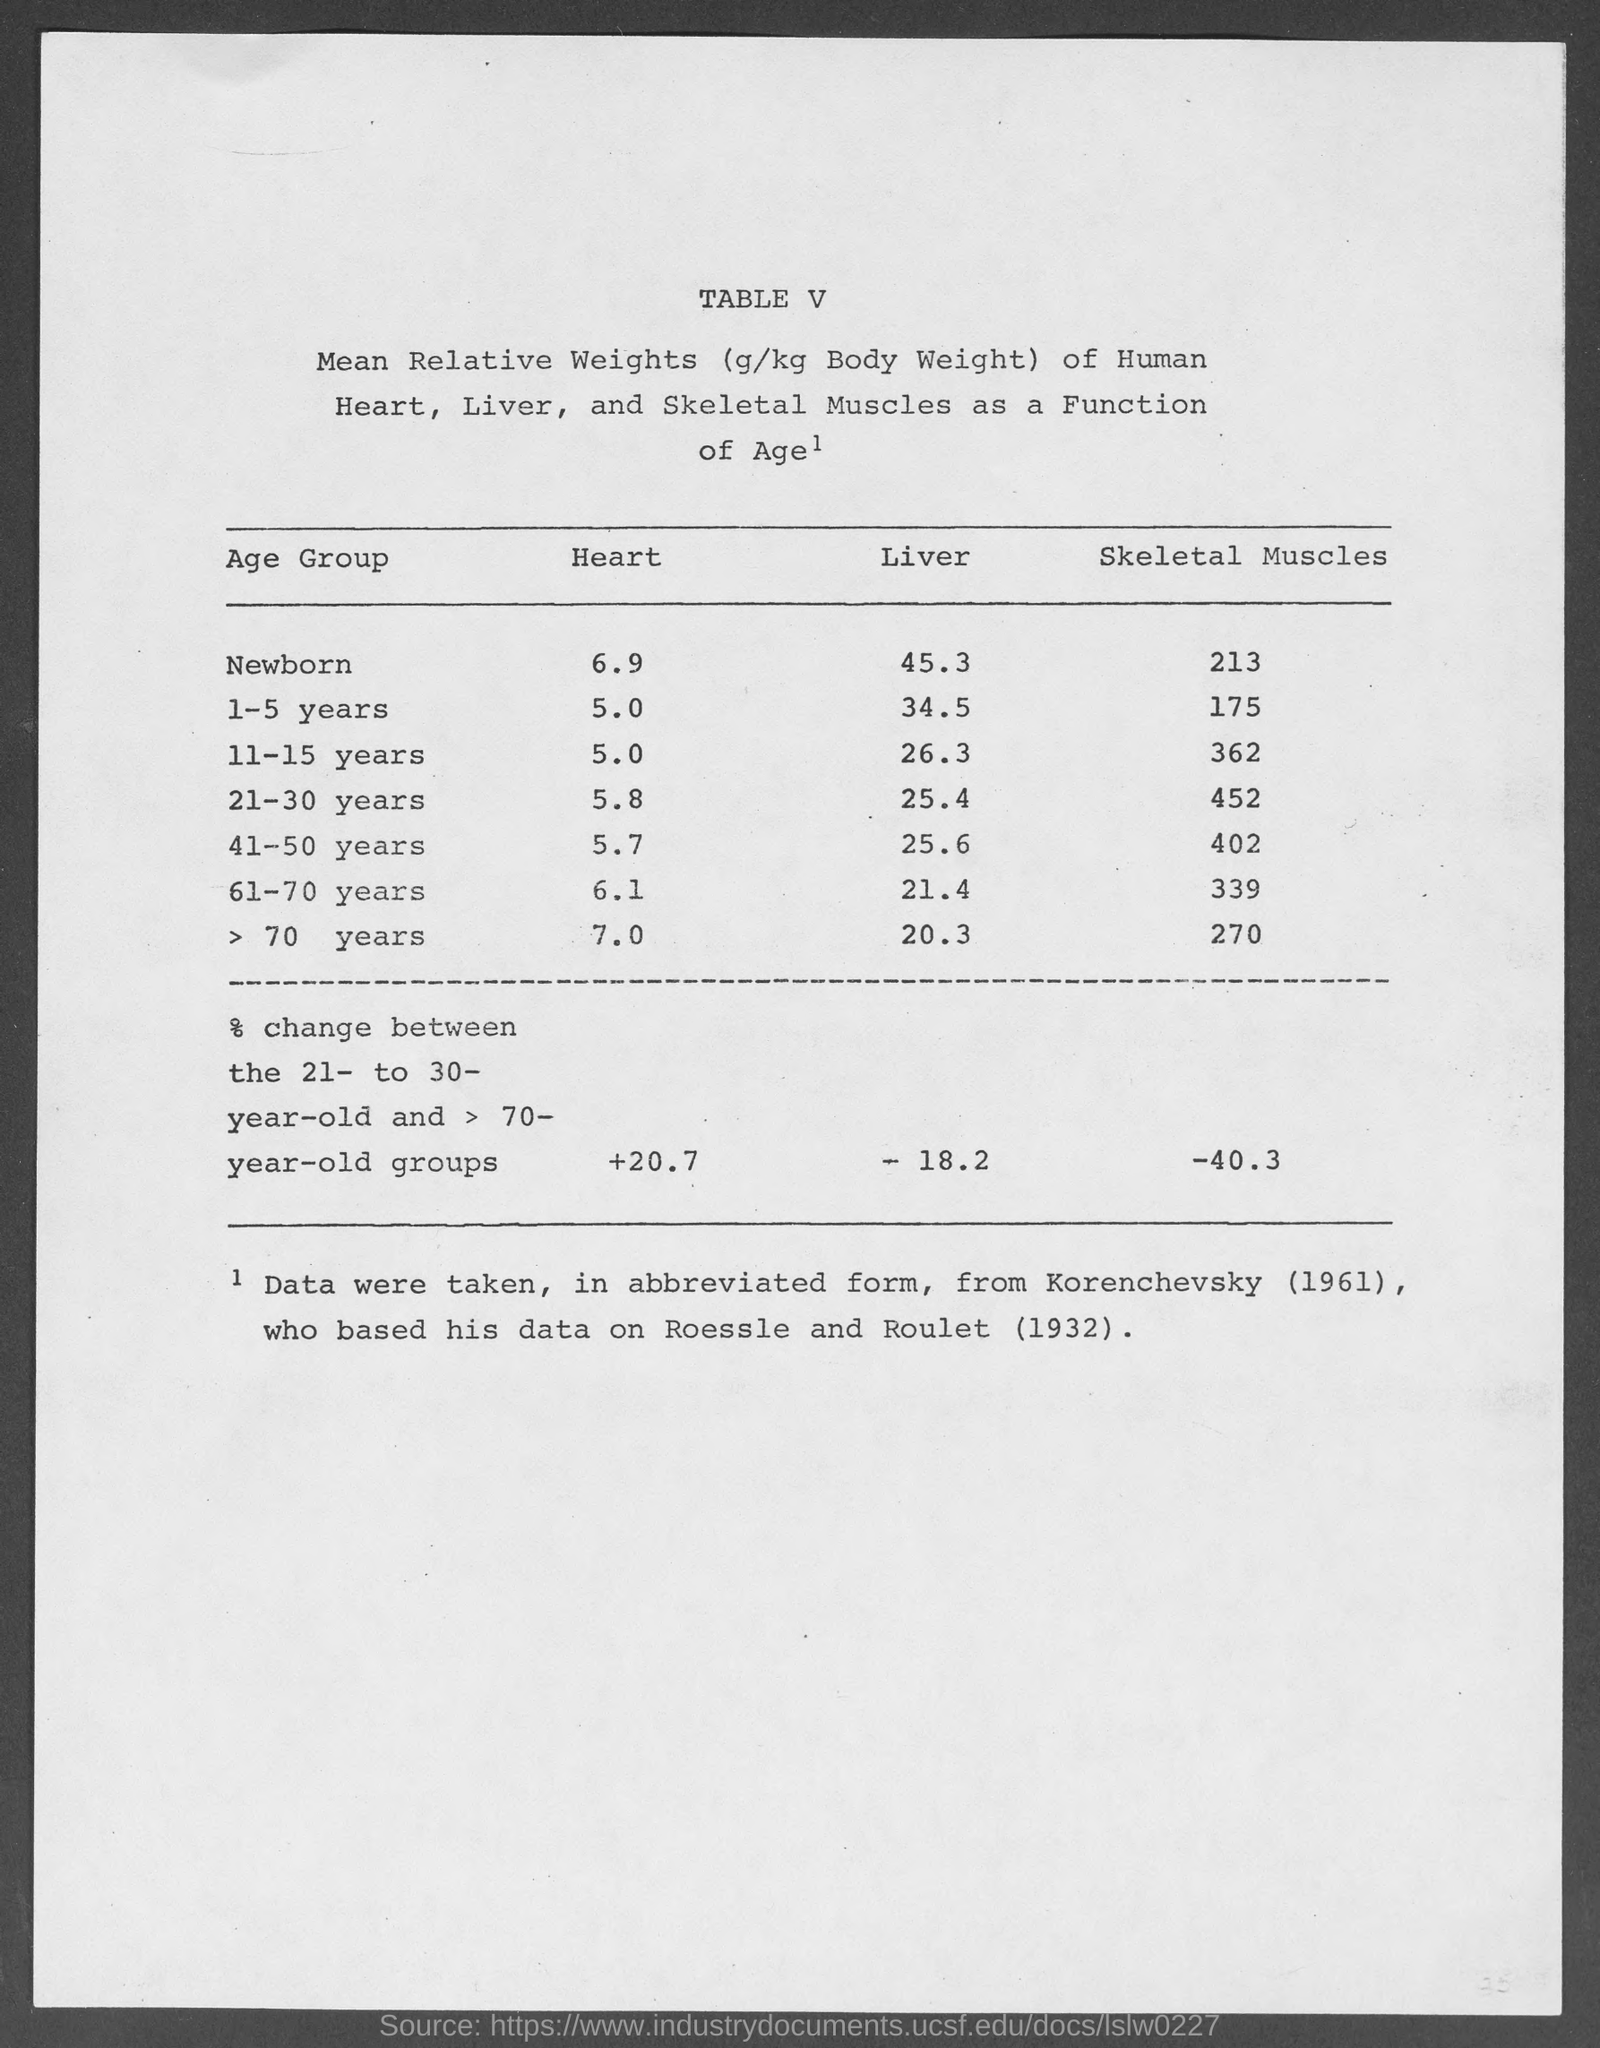What is written in capital letters as the first line at top of this document ?
Your answer should be very brief. Table V. What is the value written under heading Heart for Newborn ?
Ensure brevity in your answer.  6.9. What is the value written under heading Skeletal Muscles for 21-30 years ?
Your answer should be compact. 452. What is the value written under Liver for 11-15 years ?
Your response must be concise. 26.3. What is the value of % change between the 21- to 30- year old and > 70- year-old groups under heading Skeletal Muscles ?
Your answer should be compact. -40.3. What is the value given in parenthesis along with the word Korenchevsky ?
Make the answer very short. 1961. What is the value written under heading Heart for age group 41-50 years ?
Your response must be concise. 5.7. What is the value written under heading liver for age group 61-70 years?
Keep it short and to the point. 21.4. What is the value written under heading Skeletal Muscles for Newborn ?
Provide a short and direct response. 213. Mean Relative Weights of which Human body parts are given here in this chart ?
Provide a short and direct response. Heart, Liver, and Skeletal Muscles. 